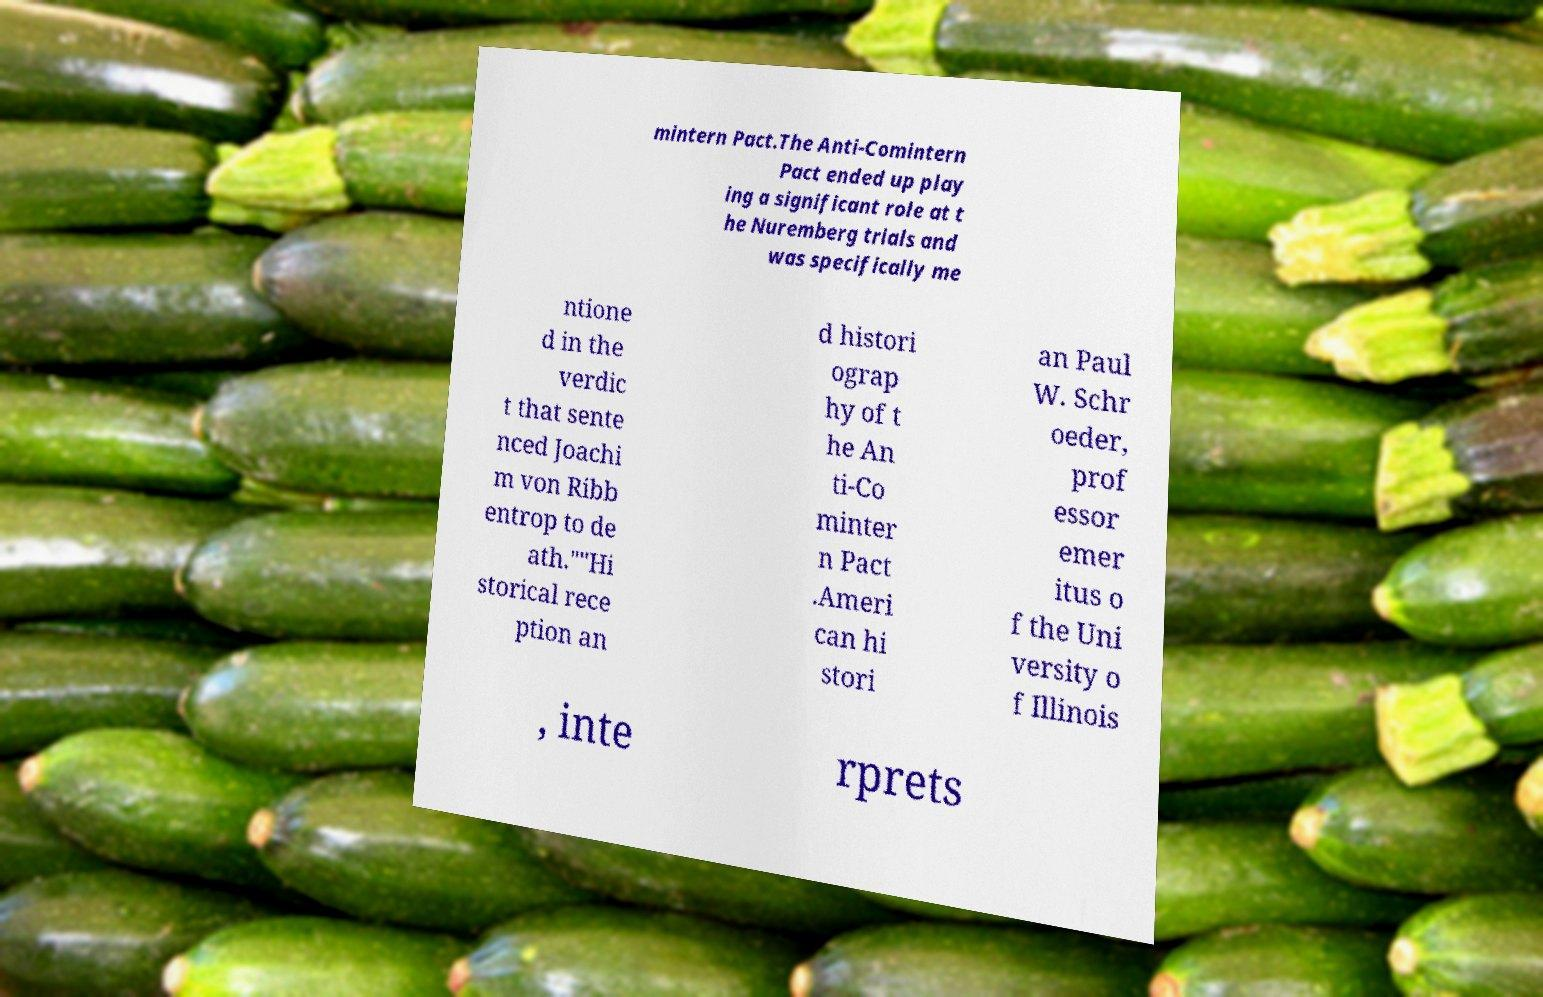There's text embedded in this image that I need extracted. Can you transcribe it verbatim? mintern Pact.The Anti-Comintern Pact ended up play ing a significant role at t he Nuremberg trials and was specifically me ntione d in the verdic t that sente nced Joachi m von Ribb entrop to de ath.""Hi storical rece ption an d histori ograp hy of t he An ti-Co minter n Pact .Ameri can hi stori an Paul W. Schr oeder, prof essor emer itus o f the Uni versity o f Illinois , inte rprets 